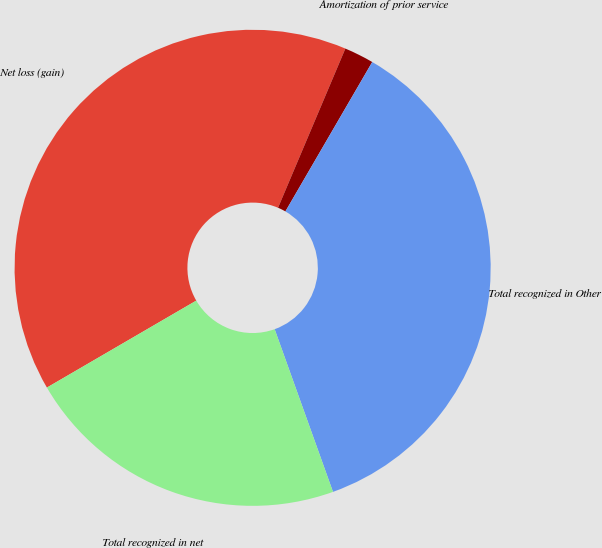<chart> <loc_0><loc_0><loc_500><loc_500><pie_chart><fcel>Net loss (gain)<fcel>Amortization of prior service<fcel>Total recognized in Other<fcel>Total recognized in net<nl><fcel>39.76%<fcel>2.01%<fcel>36.14%<fcel>22.09%<nl></chart> 